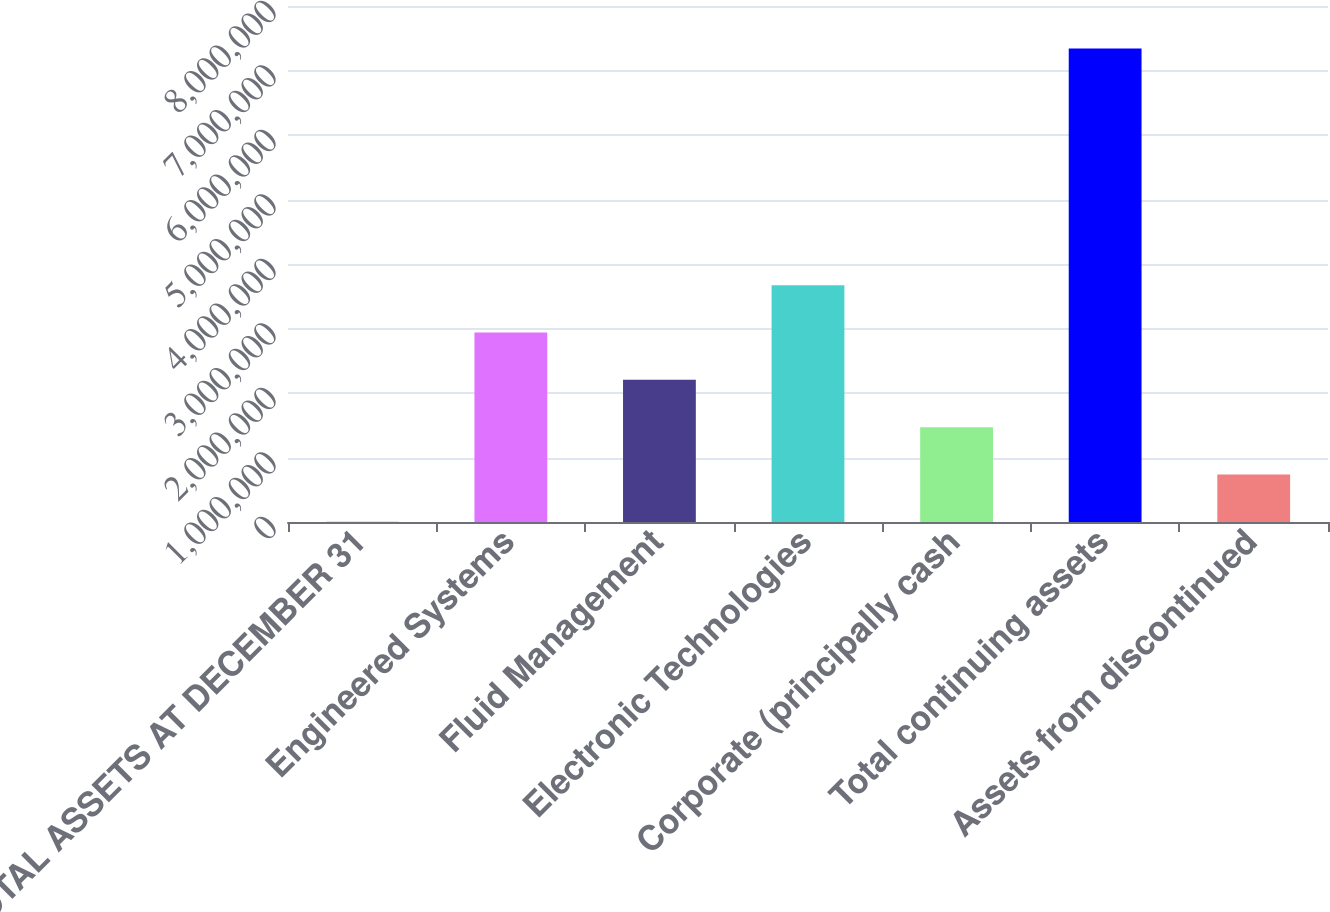Convert chart to OTSL. <chart><loc_0><loc_0><loc_500><loc_500><bar_chart><fcel>TOTAL ASSETS AT DECEMBER 31<fcel>Engineered Systems<fcel>Fluid Management<fcel>Electronic Technologies<fcel>Corporate (principally cash<fcel>Total continuing assets<fcel>Assets from discontinued<nl><fcel>2006<fcel>2.93835e+06<fcel>2.20426e+06<fcel>3.67244e+06<fcel>1.47018e+06<fcel>7.34287e+06<fcel>736092<nl></chart> 